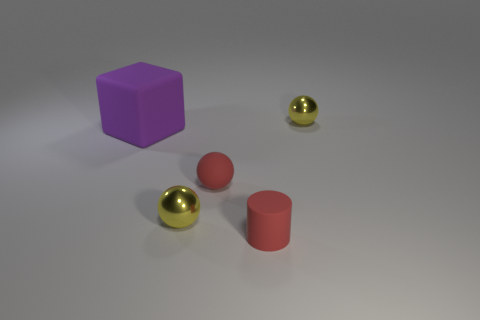What materials do the objects in the image seem to be made of? The objects in the image give the impression of being made from different materials. The cube appears to have a matte finish, suggesting a plastic-like material, whereas the two spheres seem to have a reflective surface, which could indicate a metallic material, and the cylinder looks like it may have a painted or coated finish similar to ceramics or metal. 